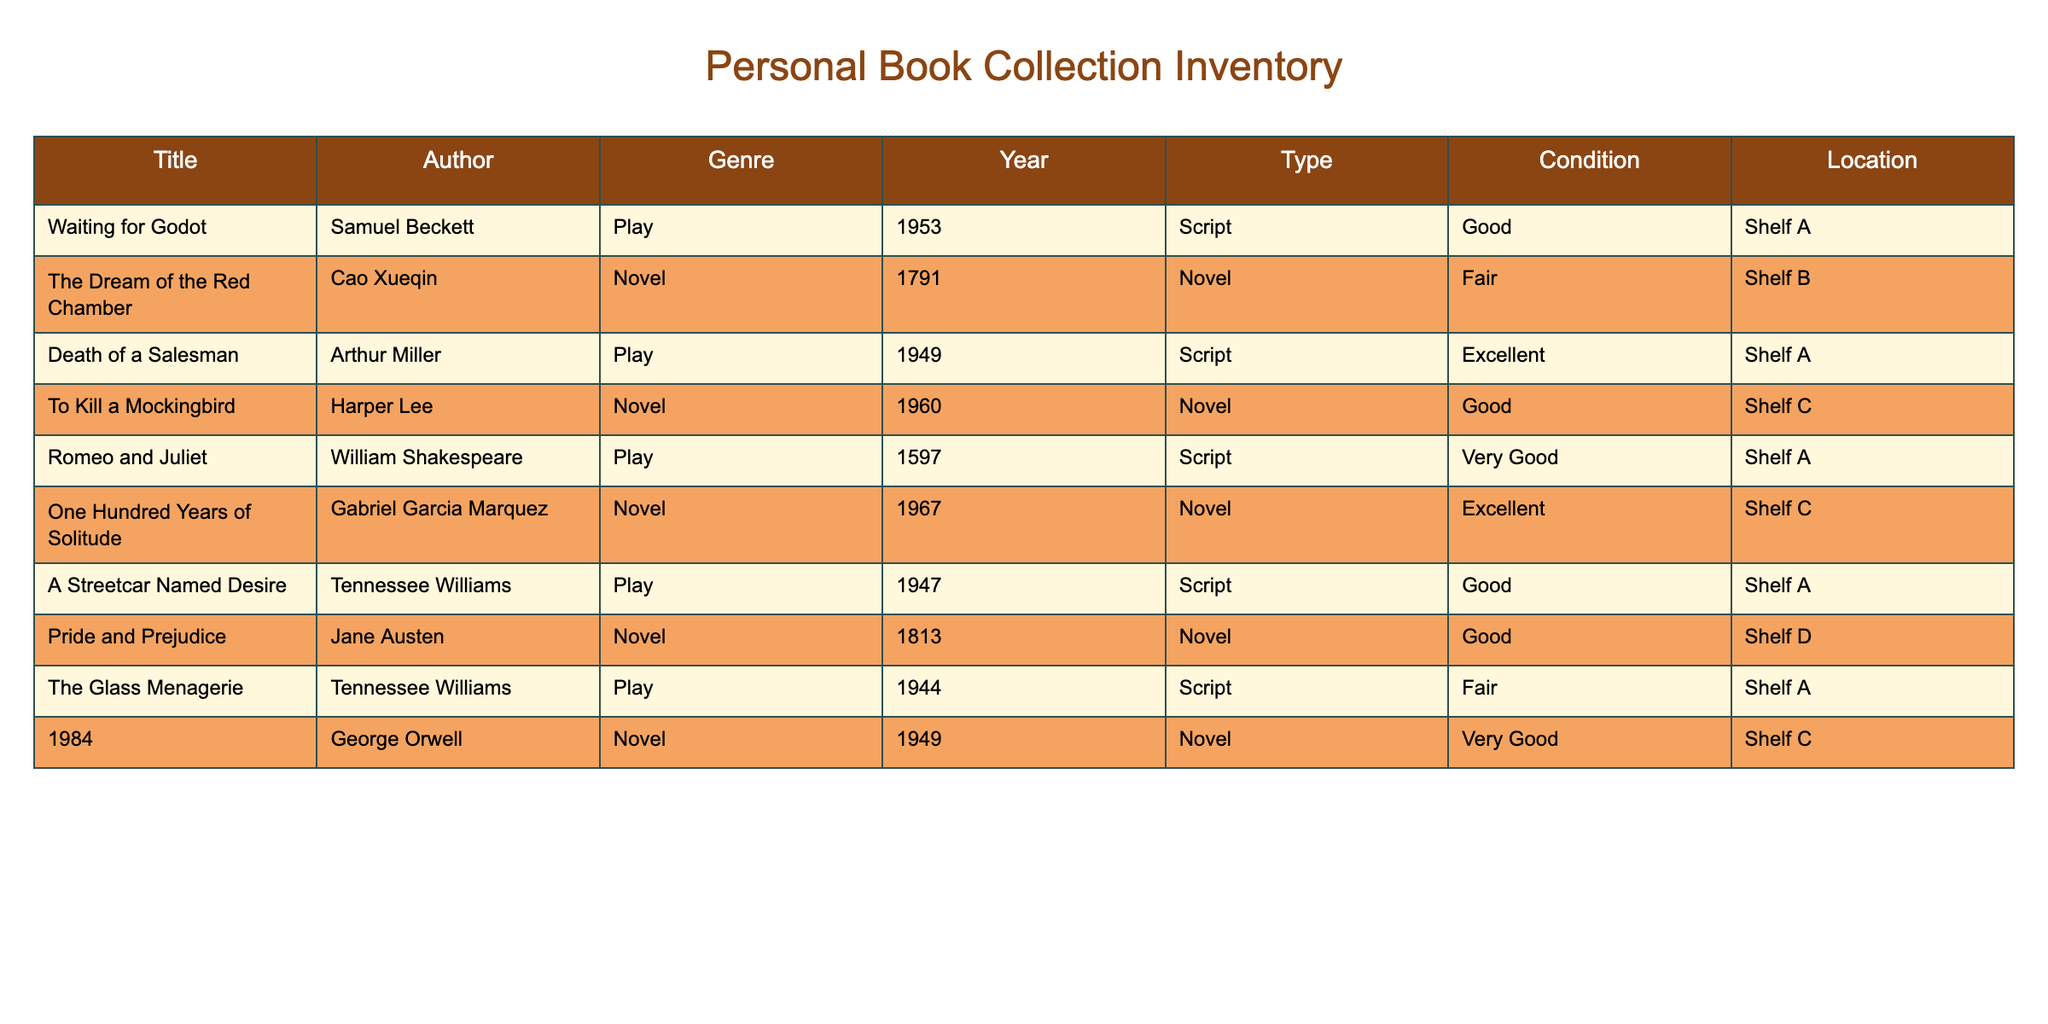What is the title of the book written by William Shakespeare? The title of the book by William Shakespeare can be found in the "Title" column where the "Author" column matches "William Shakespeare." The book is "Romeo and Juliet."
Answer: Romeo and Juliet How many novels are in my collection? To find the number of novels, count the rows where "Type" is "Novel." There are four novels: "The Dream of the Red Chamber," "To Kill a Mockingbird," "One Hundred Years of Solitude," and "Pride and Prejudice."
Answer: 4 Which book in my collection is in "Excellent" condition? Looking through the "Condition" column, the titles corresponding to "Excellent" condition are "Death of a Salesman" and "One Hundred Years of Solitude."
Answer: Death of a Salesman, One Hundred Years of Solitude What is the average year of publication for the novels in my collection? The years of publication for the novels are 1791, 1960, 1967, and 1813. To find the average, sum these years: 1791 + 1960 + 1967 + 1813 = 7541, then divide by 4 (the number of novels): 7541 / 4 = 1885.25.
Answer: 1885.25 Is there any book by Arthur Miller in my collection? Check the "Author" column for "Arthur Miller." The book "Death of a Salesman" confirms that yes, Arthur Miller's work is included in the collection.
Answer: Yes What is the condition of "A Streetcar Named Desire"? Look up "A Streetcar Named Desire" in the "Title" column, and see the corresponding entry in the "Condition" column. It is listed as "Good."
Answer: Good Which shelf has the most books in my collection? Count the number of entries for each shelf (Shelf A, Shelf B, Shelf C, Shelf D). Shelf A has five books, while Shelf B has one, Shelf C has three, and Shelf D has one. Therefore, Shelf A has the most books.
Answer: Shelf A Are there any plays in my collection written after 1950? Check the "Type" and "Year" columns. "Waiting for Godot" (1953), "Death of a Salesman" (1949), and "A Streetcar Named Desire" (1947) are the relevant entries. Only "Waiting for Godot" meets the criteria, so the answer is yes.
Answer: Yes 